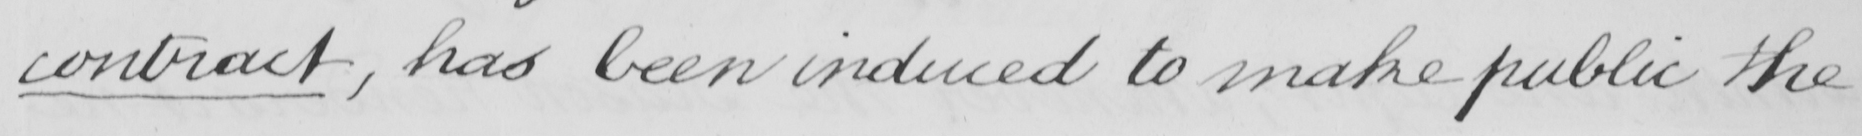What is written in this line of handwriting? contract , has been induced to make public the 